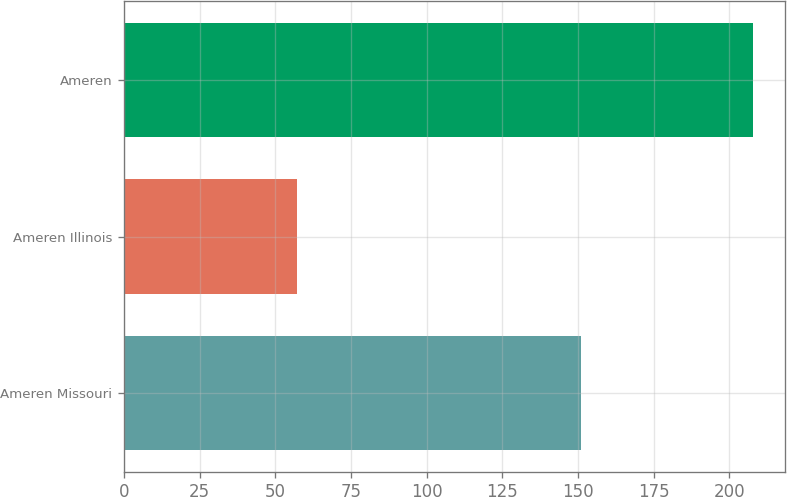Convert chart. <chart><loc_0><loc_0><loc_500><loc_500><bar_chart><fcel>Ameren Missouri<fcel>Ameren Illinois<fcel>Ameren<nl><fcel>151<fcel>57<fcel>208<nl></chart> 